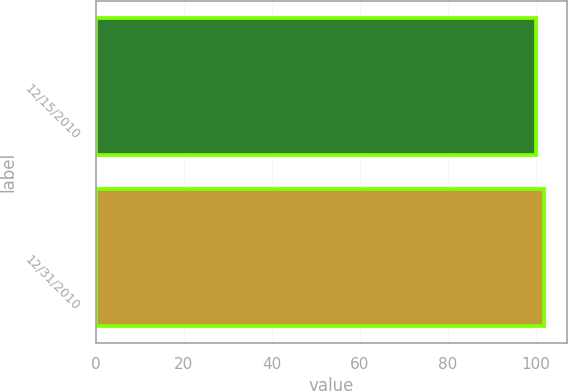Convert chart. <chart><loc_0><loc_0><loc_500><loc_500><bar_chart><fcel>12/15/2010<fcel>12/31/2010<nl><fcel>100<fcel>101.99<nl></chart> 